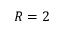<formula> <loc_0><loc_0><loc_500><loc_500>R = 2</formula> 